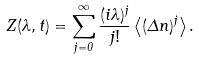Convert formula to latex. <formula><loc_0><loc_0><loc_500><loc_500>Z ( \lambda , t ) = \sum _ { j = 0 } ^ { \infty } \frac { ( i \lambda ) ^ { j } } { j ! } \left < ( \Delta n ) ^ { j } \right > .</formula> 